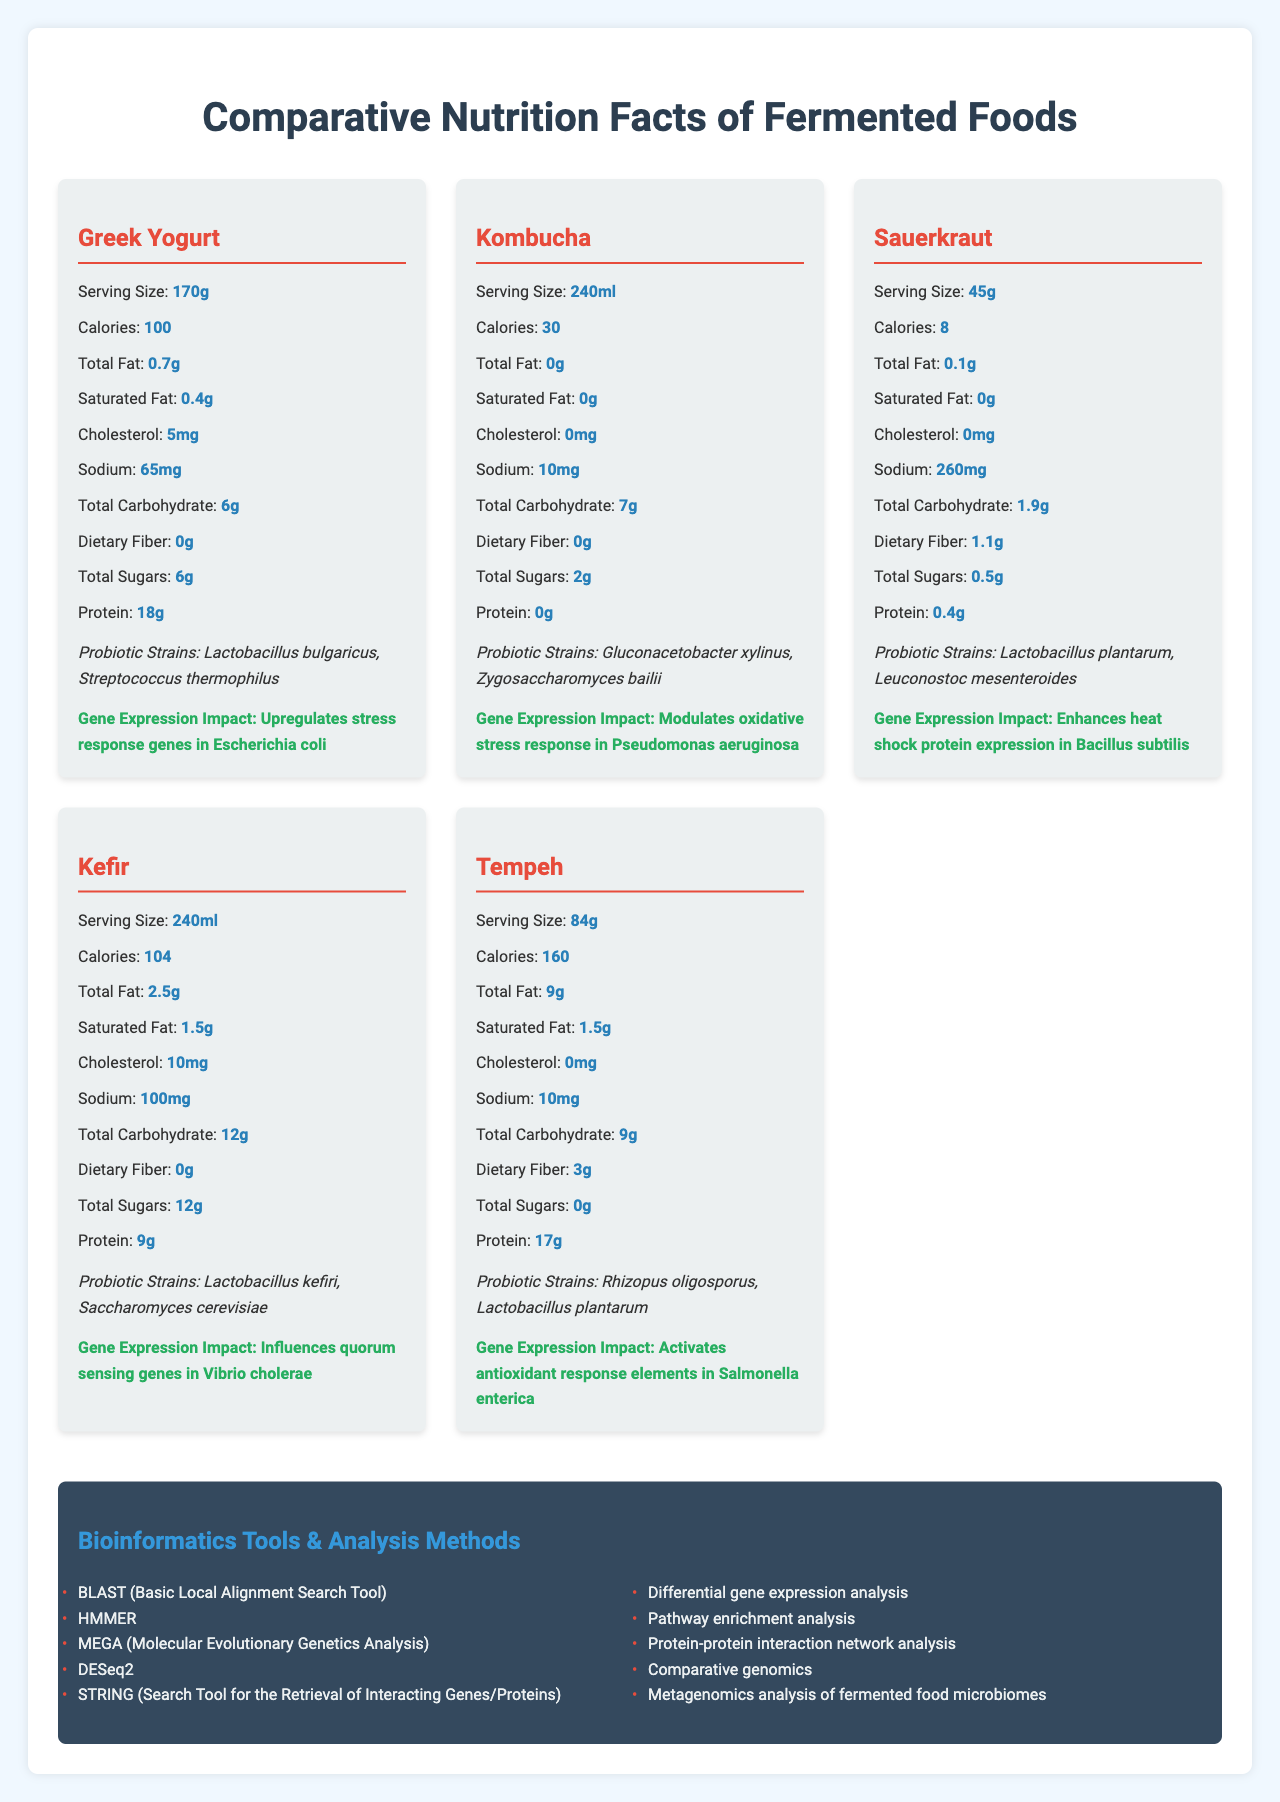What is the serving size of Greek Yogurt? The serving size of Greek Yogurt is listed as 170g under its nutrition facts.
Answer: 170g How many calories does Kombucha contain per serving? According to the document, Kombucha contains 30 calories per serving of 240ml.
Answer: 30 What probiotic strains are found in Sauerkraut? The probiotic strains listed for Sauerkraut are Lactobacillus plantarum and Leuconostoc mesenteroides.
Answer: Lactobacillus plantarum, Leuconostoc mesenteroides Which fermented food has the highest protein content per serving? Greek Yogurt contains 18g of protein per serving, which is the highest among the listed fermented foods.
Answer: Greek Yogurt What gene expression impact does Tempeh have? The gene expression impact of Tempeh is listed as activating antioxidant response elements in Salmonella enterica.
Answer: Activates antioxidant response elements in Salmonella enterica Which fermented food has the lowest sodium content? A. Greek Yogurt B. Kefir C. Tempeh D. Sauerkraut Tempeh has 10mg of sodium per serving, which is the lowest among the options listed.
Answer: C. Tempeh How much Vitamin D does Kefir contain? A. 0 IU B. 20 IU C. 50 IU D. 100 IU Kefir contains 100 IU of Vitamin D per serving according to its nutrition facts.
Answer: D. 100 IU Does Sauerkraut contain dietary fiber? (True/False) Sauerkraut contains 1.1g of dietary fiber per serving.
Answer: True Summarize the main idea of the document. This summary outlines the key elements and purpose of the document, which is to present a comparison of different fermented foods regarding their nutritional content and probiotic benefits, along with mentioning the bioinformatics tools for data analysis.
Answer: The document provides comparative nutrition facts for various fermented foods rich in beneficial bacteria, detailing their serving sizes, calories, macronutrients, probiotics, and specific impacts on bacterial gene expression. Additionally, it lists relevant bioinformatics tools and stress response genes used in the analysis. What is the price of the Greek Yogurt listed? The document does not provide any pricing information for the Greek Yogurt or any other fermented food.
Answer: Not enough information 